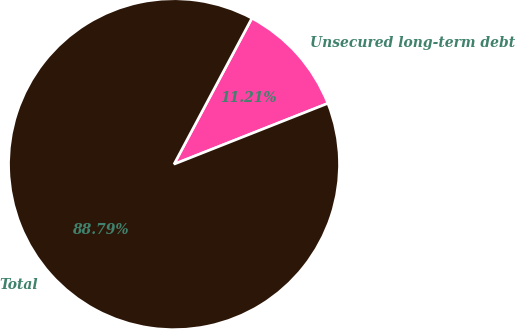<chart> <loc_0><loc_0><loc_500><loc_500><pie_chart><fcel>Unsecured long-term debt<fcel>Total<nl><fcel>11.21%<fcel>88.79%<nl></chart> 